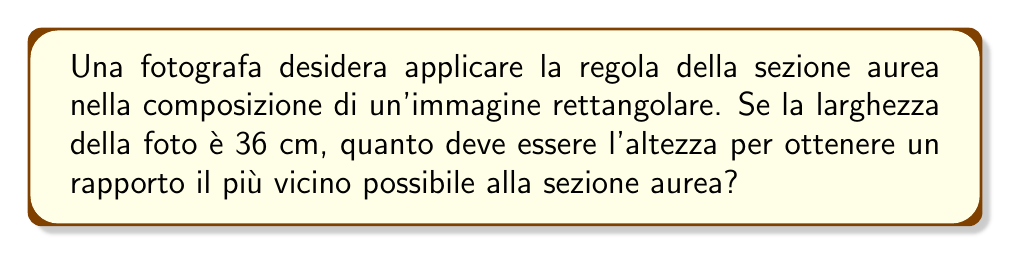Show me your answer to this math problem. Per risolvere questo problema, seguiamo questi passaggi:

1) La sezione aurea, o rapporto aureo, è approssimativamente 1.618034...

2) Se indichiamo la larghezza con $w$ e l'altezza con $h$, vogliamo che:

   $$\frac{w}{h} \approx 1.618034$$

3) Sappiamo che $w = 36$ cm, quindi:

   $$\frac{36}{h} \approx 1.618034$$

4) Per trovare $h$, risolviamo l'equazione:

   $$h \approx \frac{36}{1.618034}$$

5) Calcoliamo:

   $$h \approx 22.24845 \text{ cm}$$

6) Poiché le dimensioni delle foto sono generalmente arrotondate al millimetro, approssimiamo a 22.2 cm.

7) Verifichiamo il rapporto:

   $$\frac{36}{22.2} \approx 1.621621$$

Questo è molto vicino al rapporto aureo di 1.618034, con una differenza di solo circa 0.22%.
Answer: 22.2 cm 